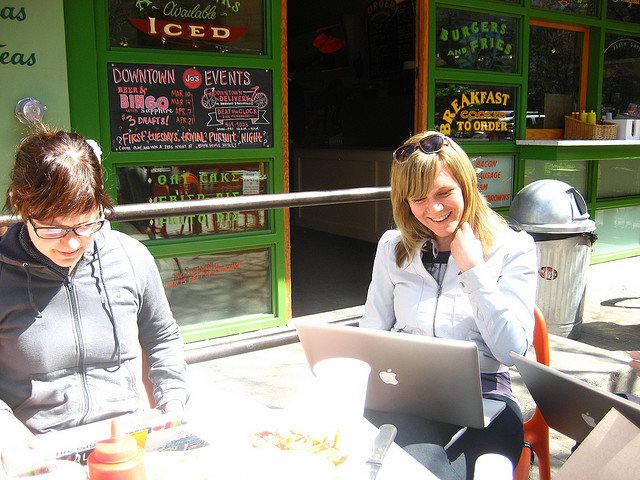Please extract the text content from this image. COOKIE TO ORDER BURGERS AND FRIES PIE CAKE O A I MAT BEER BINGO CRAFTS! 3 NIGHT FIRST CLOCL BEAT DELIVERY EVENTS JOB DOWNTOWN ICED available eas as 